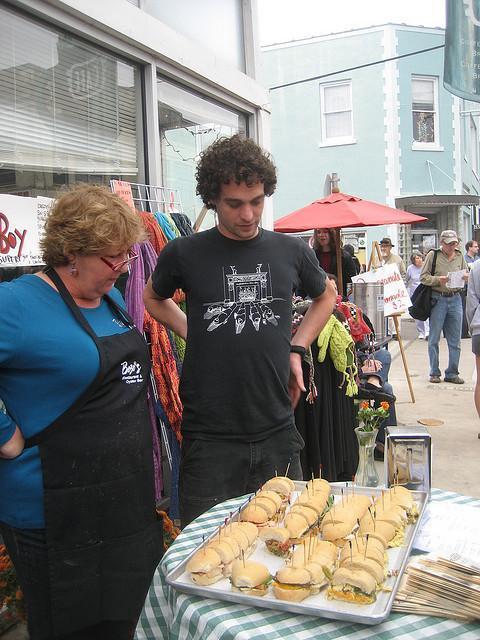How many people are there?
Give a very brief answer. 4. 